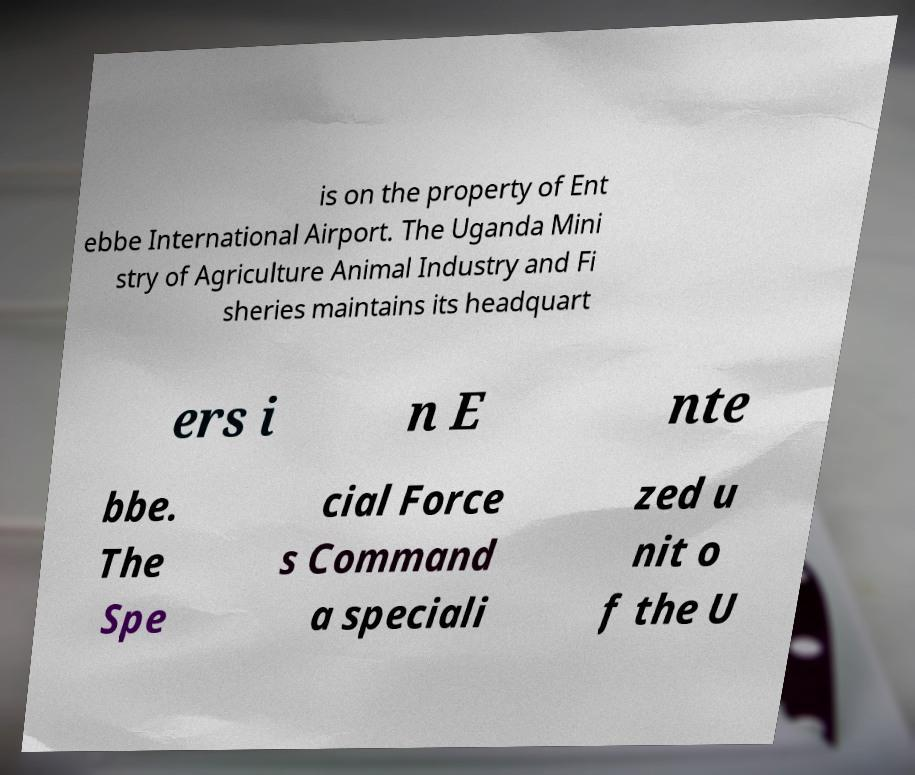I need the written content from this picture converted into text. Can you do that? is on the property of Ent ebbe International Airport. The Uganda Mini stry of Agriculture Animal Industry and Fi sheries maintains its headquart ers i n E nte bbe. The Spe cial Force s Command a speciali zed u nit o f the U 